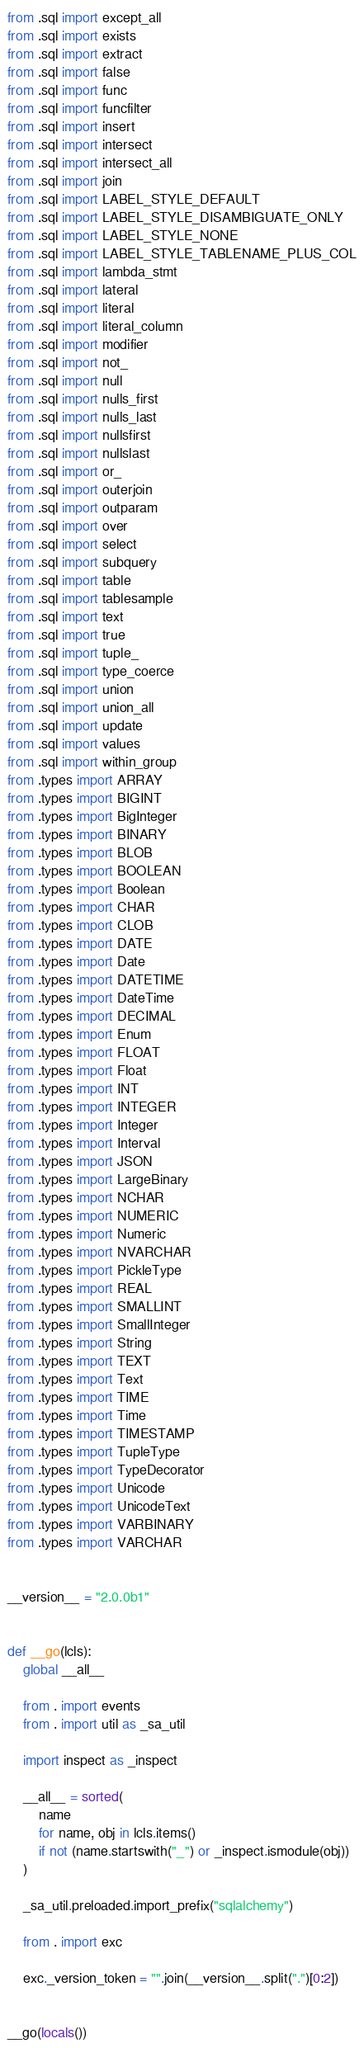<code> <loc_0><loc_0><loc_500><loc_500><_Python_>from .sql import except_all
from .sql import exists
from .sql import extract
from .sql import false
from .sql import func
from .sql import funcfilter
from .sql import insert
from .sql import intersect
from .sql import intersect_all
from .sql import join
from .sql import LABEL_STYLE_DEFAULT
from .sql import LABEL_STYLE_DISAMBIGUATE_ONLY
from .sql import LABEL_STYLE_NONE
from .sql import LABEL_STYLE_TABLENAME_PLUS_COL
from .sql import lambda_stmt
from .sql import lateral
from .sql import literal
from .sql import literal_column
from .sql import modifier
from .sql import not_
from .sql import null
from .sql import nulls_first
from .sql import nulls_last
from .sql import nullsfirst
from .sql import nullslast
from .sql import or_
from .sql import outerjoin
from .sql import outparam
from .sql import over
from .sql import select
from .sql import subquery
from .sql import table
from .sql import tablesample
from .sql import text
from .sql import true
from .sql import tuple_
from .sql import type_coerce
from .sql import union
from .sql import union_all
from .sql import update
from .sql import values
from .sql import within_group
from .types import ARRAY
from .types import BIGINT
from .types import BigInteger
from .types import BINARY
from .types import BLOB
from .types import BOOLEAN
from .types import Boolean
from .types import CHAR
from .types import CLOB
from .types import DATE
from .types import Date
from .types import DATETIME
from .types import DateTime
from .types import DECIMAL
from .types import Enum
from .types import FLOAT
from .types import Float
from .types import INT
from .types import INTEGER
from .types import Integer
from .types import Interval
from .types import JSON
from .types import LargeBinary
from .types import NCHAR
from .types import NUMERIC
from .types import Numeric
from .types import NVARCHAR
from .types import PickleType
from .types import REAL
from .types import SMALLINT
from .types import SmallInteger
from .types import String
from .types import TEXT
from .types import Text
from .types import TIME
from .types import Time
from .types import TIMESTAMP
from .types import TupleType
from .types import TypeDecorator
from .types import Unicode
from .types import UnicodeText
from .types import VARBINARY
from .types import VARCHAR


__version__ = "2.0.0b1"


def __go(lcls):
    global __all__

    from . import events
    from . import util as _sa_util

    import inspect as _inspect

    __all__ = sorted(
        name
        for name, obj in lcls.items()
        if not (name.startswith("_") or _inspect.ismodule(obj))
    )

    _sa_util.preloaded.import_prefix("sqlalchemy")

    from . import exc

    exc._version_token = "".join(__version__.split(".")[0:2])


__go(locals())
</code> 